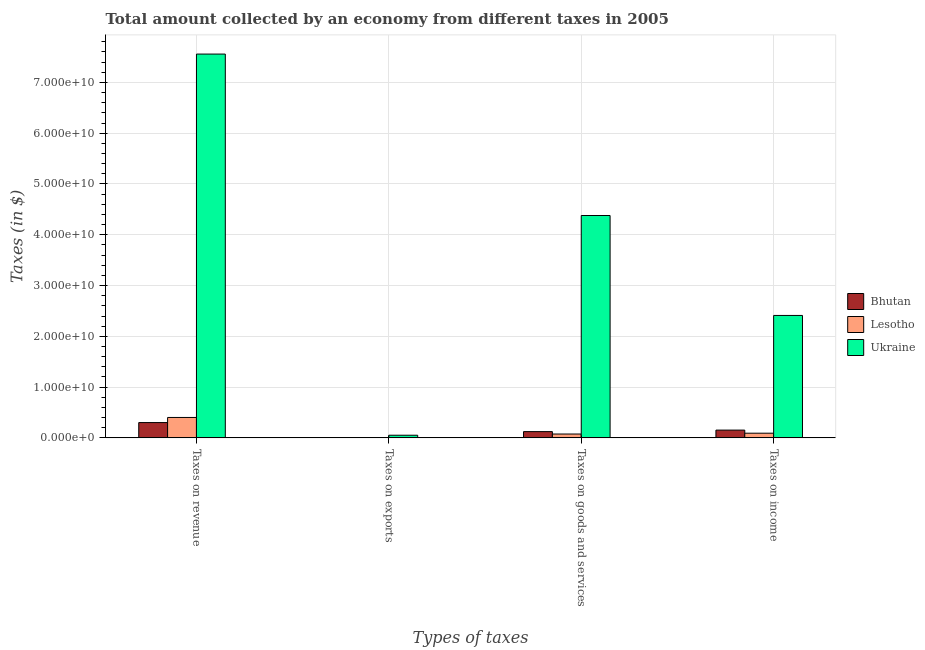How many groups of bars are there?
Your answer should be compact. 4. Are the number of bars on each tick of the X-axis equal?
Ensure brevity in your answer.  Yes. How many bars are there on the 2nd tick from the left?
Make the answer very short. 3. How many bars are there on the 4th tick from the right?
Offer a terse response. 3. What is the label of the 2nd group of bars from the left?
Offer a terse response. Taxes on exports. What is the amount collected as tax on revenue in Ukraine?
Ensure brevity in your answer.  7.56e+1. Across all countries, what is the maximum amount collected as tax on goods?
Keep it short and to the point. 4.38e+1. Across all countries, what is the minimum amount collected as tax on revenue?
Ensure brevity in your answer.  3.01e+09. In which country was the amount collected as tax on income maximum?
Offer a very short reply. Ukraine. In which country was the amount collected as tax on exports minimum?
Give a very brief answer. Bhutan. What is the total amount collected as tax on goods in the graph?
Ensure brevity in your answer.  4.58e+1. What is the difference between the amount collected as tax on revenue in Lesotho and that in Bhutan?
Your response must be concise. 1.01e+09. What is the difference between the amount collected as tax on revenue in Lesotho and the amount collected as tax on income in Ukraine?
Ensure brevity in your answer.  -2.01e+1. What is the average amount collected as tax on goods per country?
Provide a succinct answer. 1.53e+1. What is the difference between the amount collected as tax on goods and amount collected as tax on revenue in Ukraine?
Offer a terse response. -3.18e+1. What is the ratio of the amount collected as tax on income in Bhutan to that in Ukraine?
Offer a very short reply. 0.06. What is the difference between the highest and the second highest amount collected as tax on revenue?
Give a very brief answer. 7.16e+1. What is the difference between the highest and the lowest amount collected as tax on exports?
Keep it short and to the point. 5.20e+08. What does the 3rd bar from the left in Taxes on goods and services represents?
Give a very brief answer. Ukraine. What does the 2nd bar from the right in Taxes on goods and services represents?
Provide a succinct answer. Lesotho. Is it the case that in every country, the sum of the amount collected as tax on revenue and amount collected as tax on exports is greater than the amount collected as tax on goods?
Make the answer very short. Yes. How many bars are there?
Your answer should be compact. 12. What is the difference between two consecutive major ticks on the Y-axis?
Your answer should be compact. 1.00e+1. How many legend labels are there?
Keep it short and to the point. 3. What is the title of the graph?
Offer a very short reply. Total amount collected by an economy from different taxes in 2005. What is the label or title of the X-axis?
Provide a succinct answer. Types of taxes. What is the label or title of the Y-axis?
Offer a terse response. Taxes (in $). What is the Taxes (in $) of Bhutan in Taxes on revenue?
Give a very brief answer. 3.01e+09. What is the Taxes (in $) in Lesotho in Taxes on revenue?
Offer a terse response. 4.02e+09. What is the Taxes (in $) of Ukraine in Taxes on revenue?
Provide a succinct answer. 7.56e+1. What is the Taxes (in $) of Bhutan in Taxes on exports?
Your answer should be very brief. 8.70e+05. What is the Taxes (in $) in Lesotho in Taxes on exports?
Ensure brevity in your answer.  2.79e+07. What is the Taxes (in $) of Ukraine in Taxes on exports?
Make the answer very short. 5.20e+08. What is the Taxes (in $) of Bhutan in Taxes on goods and services?
Provide a succinct answer. 1.23e+09. What is the Taxes (in $) of Lesotho in Taxes on goods and services?
Provide a short and direct response. 7.58e+08. What is the Taxes (in $) in Ukraine in Taxes on goods and services?
Offer a terse response. 4.38e+1. What is the Taxes (in $) of Bhutan in Taxes on income?
Provide a short and direct response. 1.53e+09. What is the Taxes (in $) in Lesotho in Taxes on income?
Give a very brief answer. 9.20e+08. What is the Taxes (in $) of Ukraine in Taxes on income?
Ensure brevity in your answer.  2.41e+1. Across all Types of taxes, what is the maximum Taxes (in $) in Bhutan?
Your response must be concise. 3.01e+09. Across all Types of taxes, what is the maximum Taxes (in $) of Lesotho?
Keep it short and to the point. 4.02e+09. Across all Types of taxes, what is the maximum Taxes (in $) in Ukraine?
Make the answer very short. 7.56e+1. Across all Types of taxes, what is the minimum Taxes (in $) of Bhutan?
Keep it short and to the point. 8.70e+05. Across all Types of taxes, what is the minimum Taxes (in $) in Lesotho?
Provide a succinct answer. 2.79e+07. Across all Types of taxes, what is the minimum Taxes (in $) of Ukraine?
Your answer should be compact. 5.20e+08. What is the total Taxes (in $) of Bhutan in the graph?
Your answer should be very brief. 5.78e+09. What is the total Taxes (in $) in Lesotho in the graph?
Give a very brief answer. 5.73e+09. What is the total Taxes (in $) in Ukraine in the graph?
Offer a very short reply. 1.44e+11. What is the difference between the Taxes (in $) in Bhutan in Taxes on revenue and that in Taxes on exports?
Provide a succinct answer. 3.01e+09. What is the difference between the Taxes (in $) of Lesotho in Taxes on revenue and that in Taxes on exports?
Offer a very short reply. 3.99e+09. What is the difference between the Taxes (in $) of Ukraine in Taxes on revenue and that in Taxes on exports?
Provide a short and direct response. 7.51e+1. What is the difference between the Taxes (in $) of Bhutan in Taxes on revenue and that in Taxes on goods and services?
Make the answer very short. 1.78e+09. What is the difference between the Taxes (in $) in Lesotho in Taxes on revenue and that in Taxes on goods and services?
Give a very brief answer. 3.26e+09. What is the difference between the Taxes (in $) of Ukraine in Taxes on revenue and that in Taxes on goods and services?
Your answer should be compact. 3.18e+1. What is the difference between the Taxes (in $) in Bhutan in Taxes on revenue and that in Taxes on income?
Provide a short and direct response. 1.48e+09. What is the difference between the Taxes (in $) in Lesotho in Taxes on revenue and that in Taxes on income?
Your response must be concise. 3.10e+09. What is the difference between the Taxes (in $) in Ukraine in Taxes on revenue and that in Taxes on income?
Your response must be concise. 5.15e+1. What is the difference between the Taxes (in $) in Bhutan in Taxes on exports and that in Taxes on goods and services?
Your answer should be compact. -1.23e+09. What is the difference between the Taxes (in $) of Lesotho in Taxes on exports and that in Taxes on goods and services?
Your answer should be compact. -7.30e+08. What is the difference between the Taxes (in $) in Ukraine in Taxes on exports and that in Taxes on goods and services?
Make the answer very short. -4.33e+1. What is the difference between the Taxes (in $) in Bhutan in Taxes on exports and that in Taxes on income?
Offer a terse response. -1.53e+09. What is the difference between the Taxes (in $) in Lesotho in Taxes on exports and that in Taxes on income?
Offer a very short reply. -8.92e+08. What is the difference between the Taxes (in $) of Ukraine in Taxes on exports and that in Taxes on income?
Ensure brevity in your answer.  -2.36e+1. What is the difference between the Taxes (in $) of Bhutan in Taxes on goods and services and that in Taxes on income?
Provide a succinct answer. -3.00e+08. What is the difference between the Taxes (in $) in Lesotho in Taxes on goods and services and that in Taxes on income?
Provide a short and direct response. -1.62e+08. What is the difference between the Taxes (in $) in Ukraine in Taxes on goods and services and that in Taxes on income?
Provide a short and direct response. 1.97e+1. What is the difference between the Taxes (in $) in Bhutan in Taxes on revenue and the Taxes (in $) in Lesotho in Taxes on exports?
Give a very brief answer. 2.99e+09. What is the difference between the Taxes (in $) in Bhutan in Taxes on revenue and the Taxes (in $) in Ukraine in Taxes on exports?
Your response must be concise. 2.49e+09. What is the difference between the Taxes (in $) of Lesotho in Taxes on revenue and the Taxes (in $) of Ukraine in Taxes on exports?
Offer a terse response. 3.50e+09. What is the difference between the Taxes (in $) in Bhutan in Taxes on revenue and the Taxes (in $) in Lesotho in Taxes on goods and services?
Give a very brief answer. 2.26e+09. What is the difference between the Taxes (in $) of Bhutan in Taxes on revenue and the Taxes (in $) of Ukraine in Taxes on goods and services?
Keep it short and to the point. -4.08e+1. What is the difference between the Taxes (in $) of Lesotho in Taxes on revenue and the Taxes (in $) of Ukraine in Taxes on goods and services?
Make the answer very short. -3.98e+1. What is the difference between the Taxes (in $) in Bhutan in Taxes on revenue and the Taxes (in $) in Lesotho in Taxes on income?
Give a very brief answer. 2.09e+09. What is the difference between the Taxes (in $) of Bhutan in Taxes on revenue and the Taxes (in $) of Ukraine in Taxes on income?
Offer a terse response. -2.11e+1. What is the difference between the Taxes (in $) in Lesotho in Taxes on revenue and the Taxes (in $) in Ukraine in Taxes on income?
Offer a very short reply. -2.01e+1. What is the difference between the Taxes (in $) in Bhutan in Taxes on exports and the Taxes (in $) in Lesotho in Taxes on goods and services?
Your response must be concise. -7.57e+08. What is the difference between the Taxes (in $) of Bhutan in Taxes on exports and the Taxes (in $) of Ukraine in Taxes on goods and services?
Your answer should be very brief. -4.38e+1. What is the difference between the Taxes (in $) in Lesotho in Taxes on exports and the Taxes (in $) in Ukraine in Taxes on goods and services?
Offer a very short reply. -4.38e+1. What is the difference between the Taxes (in $) in Bhutan in Taxes on exports and the Taxes (in $) in Lesotho in Taxes on income?
Your answer should be compact. -9.19e+08. What is the difference between the Taxes (in $) in Bhutan in Taxes on exports and the Taxes (in $) in Ukraine in Taxes on income?
Your answer should be compact. -2.41e+1. What is the difference between the Taxes (in $) in Lesotho in Taxes on exports and the Taxes (in $) in Ukraine in Taxes on income?
Provide a succinct answer. -2.41e+1. What is the difference between the Taxes (in $) of Bhutan in Taxes on goods and services and the Taxes (in $) of Lesotho in Taxes on income?
Make the answer very short. 3.10e+08. What is the difference between the Taxes (in $) in Bhutan in Taxes on goods and services and the Taxes (in $) in Ukraine in Taxes on income?
Your response must be concise. -2.29e+1. What is the difference between the Taxes (in $) in Lesotho in Taxes on goods and services and the Taxes (in $) in Ukraine in Taxes on income?
Give a very brief answer. -2.34e+1. What is the average Taxes (in $) of Bhutan per Types of taxes?
Provide a succinct answer. 1.44e+09. What is the average Taxes (in $) in Lesotho per Types of taxes?
Make the answer very short. 1.43e+09. What is the average Taxes (in $) in Ukraine per Types of taxes?
Your answer should be compact. 3.60e+1. What is the difference between the Taxes (in $) in Bhutan and Taxes (in $) in Lesotho in Taxes on revenue?
Your response must be concise. -1.01e+09. What is the difference between the Taxes (in $) of Bhutan and Taxes (in $) of Ukraine in Taxes on revenue?
Ensure brevity in your answer.  -7.26e+1. What is the difference between the Taxes (in $) of Lesotho and Taxes (in $) of Ukraine in Taxes on revenue?
Ensure brevity in your answer.  -7.16e+1. What is the difference between the Taxes (in $) of Bhutan and Taxes (in $) of Lesotho in Taxes on exports?
Provide a short and direct response. -2.71e+07. What is the difference between the Taxes (in $) in Bhutan and Taxes (in $) in Ukraine in Taxes on exports?
Keep it short and to the point. -5.20e+08. What is the difference between the Taxes (in $) in Lesotho and Taxes (in $) in Ukraine in Taxes on exports?
Give a very brief answer. -4.93e+08. What is the difference between the Taxes (in $) in Bhutan and Taxes (in $) in Lesotho in Taxes on goods and services?
Your answer should be compact. 4.72e+08. What is the difference between the Taxes (in $) of Bhutan and Taxes (in $) of Ukraine in Taxes on goods and services?
Your answer should be very brief. -4.26e+1. What is the difference between the Taxes (in $) of Lesotho and Taxes (in $) of Ukraine in Taxes on goods and services?
Your answer should be very brief. -4.30e+1. What is the difference between the Taxes (in $) of Bhutan and Taxes (in $) of Lesotho in Taxes on income?
Provide a succinct answer. 6.10e+08. What is the difference between the Taxes (in $) in Bhutan and Taxes (in $) in Ukraine in Taxes on income?
Make the answer very short. -2.26e+1. What is the difference between the Taxes (in $) in Lesotho and Taxes (in $) in Ukraine in Taxes on income?
Keep it short and to the point. -2.32e+1. What is the ratio of the Taxes (in $) of Bhutan in Taxes on revenue to that in Taxes on exports?
Your response must be concise. 3464.51. What is the ratio of the Taxes (in $) of Lesotho in Taxes on revenue to that in Taxes on exports?
Ensure brevity in your answer.  143.85. What is the ratio of the Taxes (in $) in Ukraine in Taxes on revenue to that in Taxes on exports?
Your answer should be very brief. 145.23. What is the ratio of the Taxes (in $) in Bhutan in Taxes on revenue to that in Taxes on goods and services?
Offer a very short reply. 2.45. What is the ratio of the Taxes (in $) in Lesotho in Taxes on revenue to that in Taxes on goods and services?
Provide a short and direct response. 5.3. What is the ratio of the Taxes (in $) of Ukraine in Taxes on revenue to that in Taxes on goods and services?
Make the answer very short. 1.73. What is the ratio of the Taxes (in $) of Bhutan in Taxes on revenue to that in Taxes on income?
Offer a very short reply. 1.97. What is the ratio of the Taxes (in $) of Lesotho in Taxes on revenue to that in Taxes on income?
Keep it short and to the point. 4.37. What is the ratio of the Taxes (in $) of Ukraine in Taxes on revenue to that in Taxes on income?
Keep it short and to the point. 3.14. What is the ratio of the Taxes (in $) in Bhutan in Taxes on exports to that in Taxes on goods and services?
Give a very brief answer. 0. What is the ratio of the Taxes (in $) of Lesotho in Taxes on exports to that in Taxes on goods and services?
Your answer should be very brief. 0.04. What is the ratio of the Taxes (in $) of Ukraine in Taxes on exports to that in Taxes on goods and services?
Keep it short and to the point. 0.01. What is the ratio of the Taxes (in $) of Bhutan in Taxes on exports to that in Taxes on income?
Ensure brevity in your answer.  0. What is the ratio of the Taxes (in $) in Lesotho in Taxes on exports to that in Taxes on income?
Ensure brevity in your answer.  0.03. What is the ratio of the Taxes (in $) of Ukraine in Taxes on exports to that in Taxes on income?
Your answer should be compact. 0.02. What is the ratio of the Taxes (in $) of Bhutan in Taxes on goods and services to that in Taxes on income?
Make the answer very short. 0.8. What is the ratio of the Taxes (in $) of Lesotho in Taxes on goods and services to that in Taxes on income?
Give a very brief answer. 0.82. What is the ratio of the Taxes (in $) in Ukraine in Taxes on goods and services to that in Taxes on income?
Offer a terse response. 1.82. What is the difference between the highest and the second highest Taxes (in $) of Bhutan?
Offer a terse response. 1.48e+09. What is the difference between the highest and the second highest Taxes (in $) in Lesotho?
Your answer should be compact. 3.10e+09. What is the difference between the highest and the second highest Taxes (in $) of Ukraine?
Provide a short and direct response. 3.18e+1. What is the difference between the highest and the lowest Taxes (in $) of Bhutan?
Keep it short and to the point. 3.01e+09. What is the difference between the highest and the lowest Taxes (in $) of Lesotho?
Offer a very short reply. 3.99e+09. What is the difference between the highest and the lowest Taxes (in $) of Ukraine?
Give a very brief answer. 7.51e+1. 